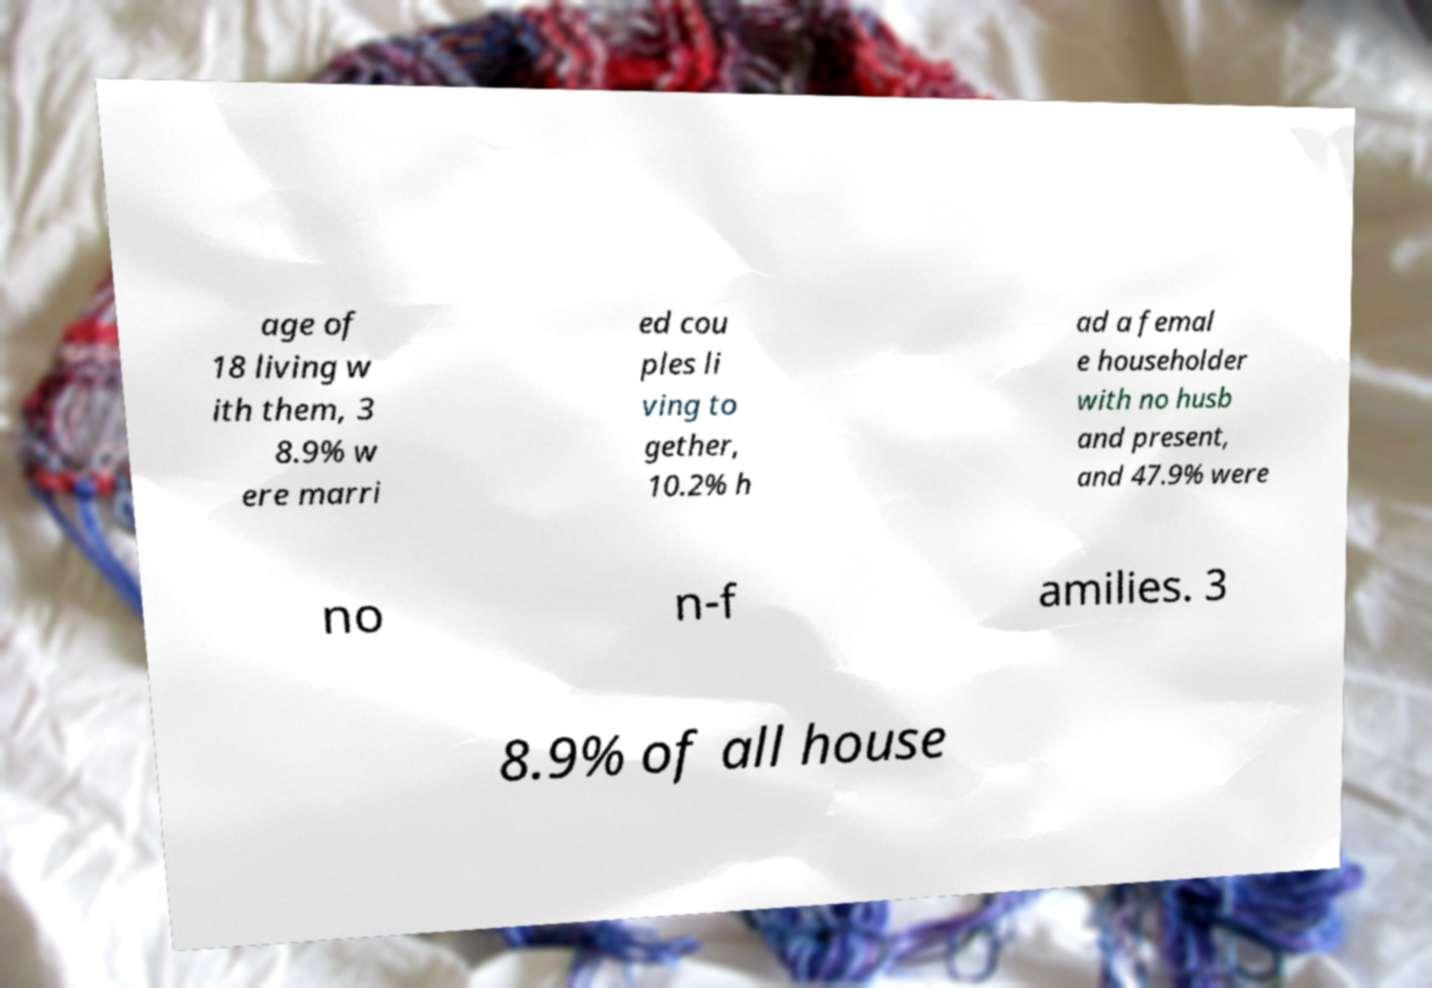Can you read and provide the text displayed in the image?This photo seems to have some interesting text. Can you extract and type it out for me? age of 18 living w ith them, 3 8.9% w ere marri ed cou ples li ving to gether, 10.2% h ad a femal e householder with no husb and present, and 47.9% were no n-f amilies. 3 8.9% of all house 